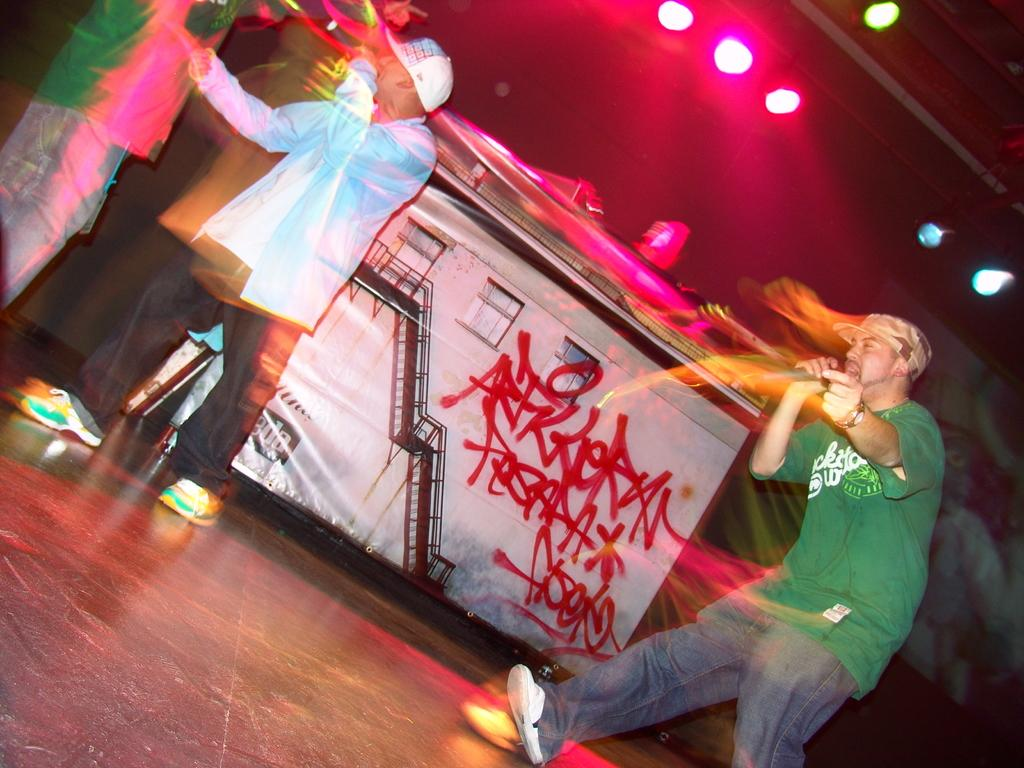What is the main subject of the image? The main subject of the image is a man. What is the man doing in the image? The man is walking and singing into a microphone. What is the man wearing in the image? The man is wearing a green t-shirt. What can be seen in the middle of the image? There are lights in the middle of the image. How many feathers are attached to the man's shoes in the image? There are no feathers attached to the man's shoes in the image. What type of spiders can be seen crawling on the microphone in the image? There are no spiders present in the image. 